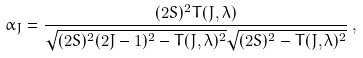<formula> <loc_0><loc_0><loc_500><loc_500>\alpha _ { J } = \frac { ( 2 S ) ^ { 2 } T ( J , \lambda ) } { \sqrt { ( 2 S ) ^ { 2 } ( 2 J - 1 ) ^ { 2 } - T ( J , \lambda ) ^ { 2 } } \sqrt { ( 2 S ) ^ { 2 } - T ( J , \lambda ) ^ { 2 } } } \, ,</formula> 